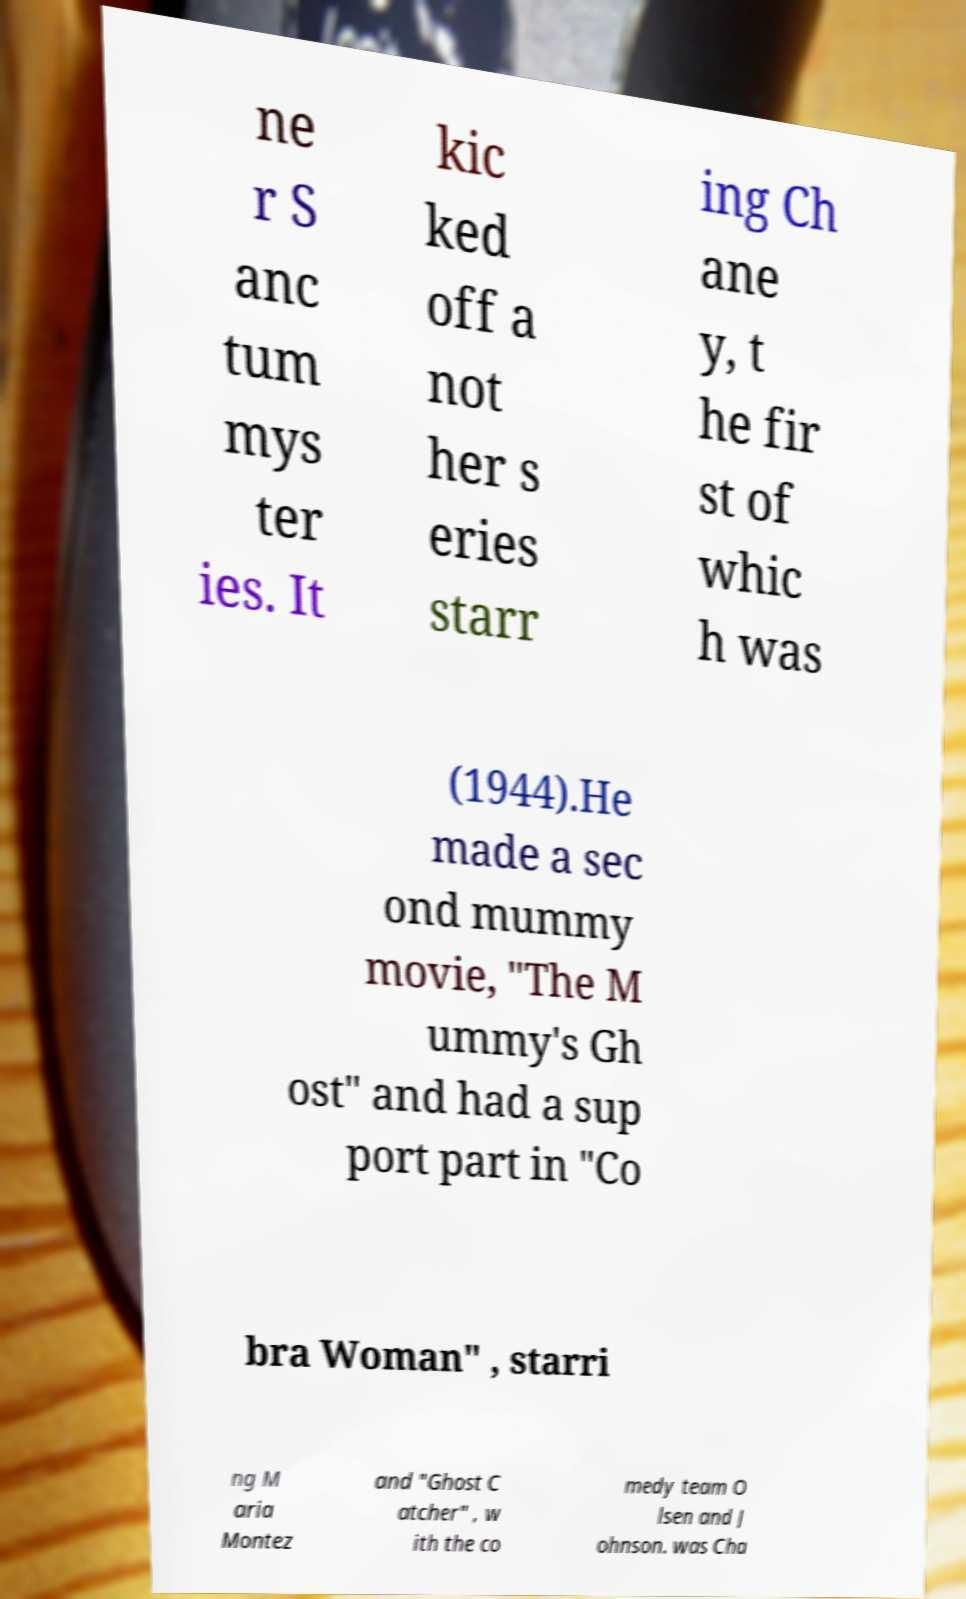There's text embedded in this image that I need extracted. Can you transcribe it verbatim? ne r S anc tum mys ter ies. It kic ked off a not her s eries starr ing Ch ane y, t he fir st of whic h was (1944).He made a sec ond mummy movie, "The M ummy's Gh ost" and had a sup port part in "Co bra Woman" , starri ng M aria Montez and "Ghost C atcher" , w ith the co medy team O lsen and J ohnson. was Cha 